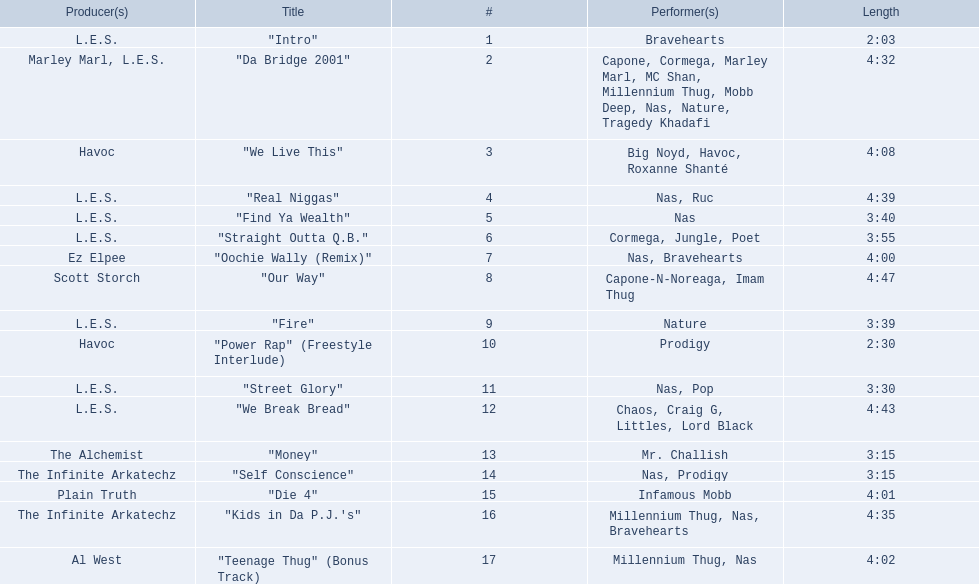What are all the song titles? "Intro", "Da Bridge 2001", "We Live This", "Real Niggas", "Find Ya Wealth", "Straight Outta Q.B.", "Oochie Wally (Remix)", "Our Way", "Fire", "Power Rap" (Freestyle Interlude), "Street Glory", "We Break Bread", "Money", "Self Conscience", "Die 4", "Kids in Da P.J.'s", "Teenage Thug" (Bonus Track). Who produced all these songs? L.E.S., Marley Marl, L.E.S., Ez Elpee, Scott Storch, Havoc, The Alchemist, The Infinite Arkatechz, Plain Truth, Al West. Of the producers, who produced the shortest song? L.E.S. How short was this producer's song? 2:03. 